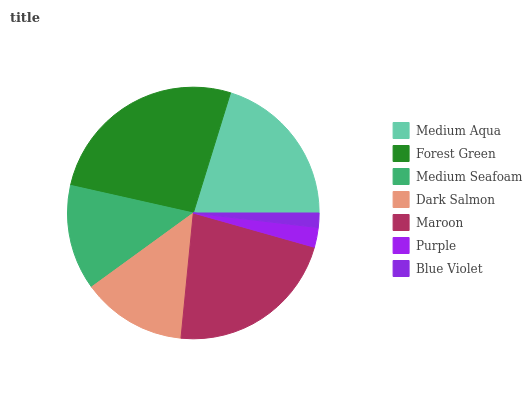Is Blue Violet the minimum?
Answer yes or no. Yes. Is Forest Green the maximum?
Answer yes or no. Yes. Is Medium Seafoam the minimum?
Answer yes or no. No. Is Medium Seafoam the maximum?
Answer yes or no. No. Is Forest Green greater than Medium Seafoam?
Answer yes or no. Yes. Is Medium Seafoam less than Forest Green?
Answer yes or no. Yes. Is Medium Seafoam greater than Forest Green?
Answer yes or no. No. Is Forest Green less than Medium Seafoam?
Answer yes or no. No. Is Medium Seafoam the high median?
Answer yes or no. Yes. Is Medium Seafoam the low median?
Answer yes or no. Yes. Is Medium Aqua the high median?
Answer yes or no. No. Is Forest Green the low median?
Answer yes or no. No. 